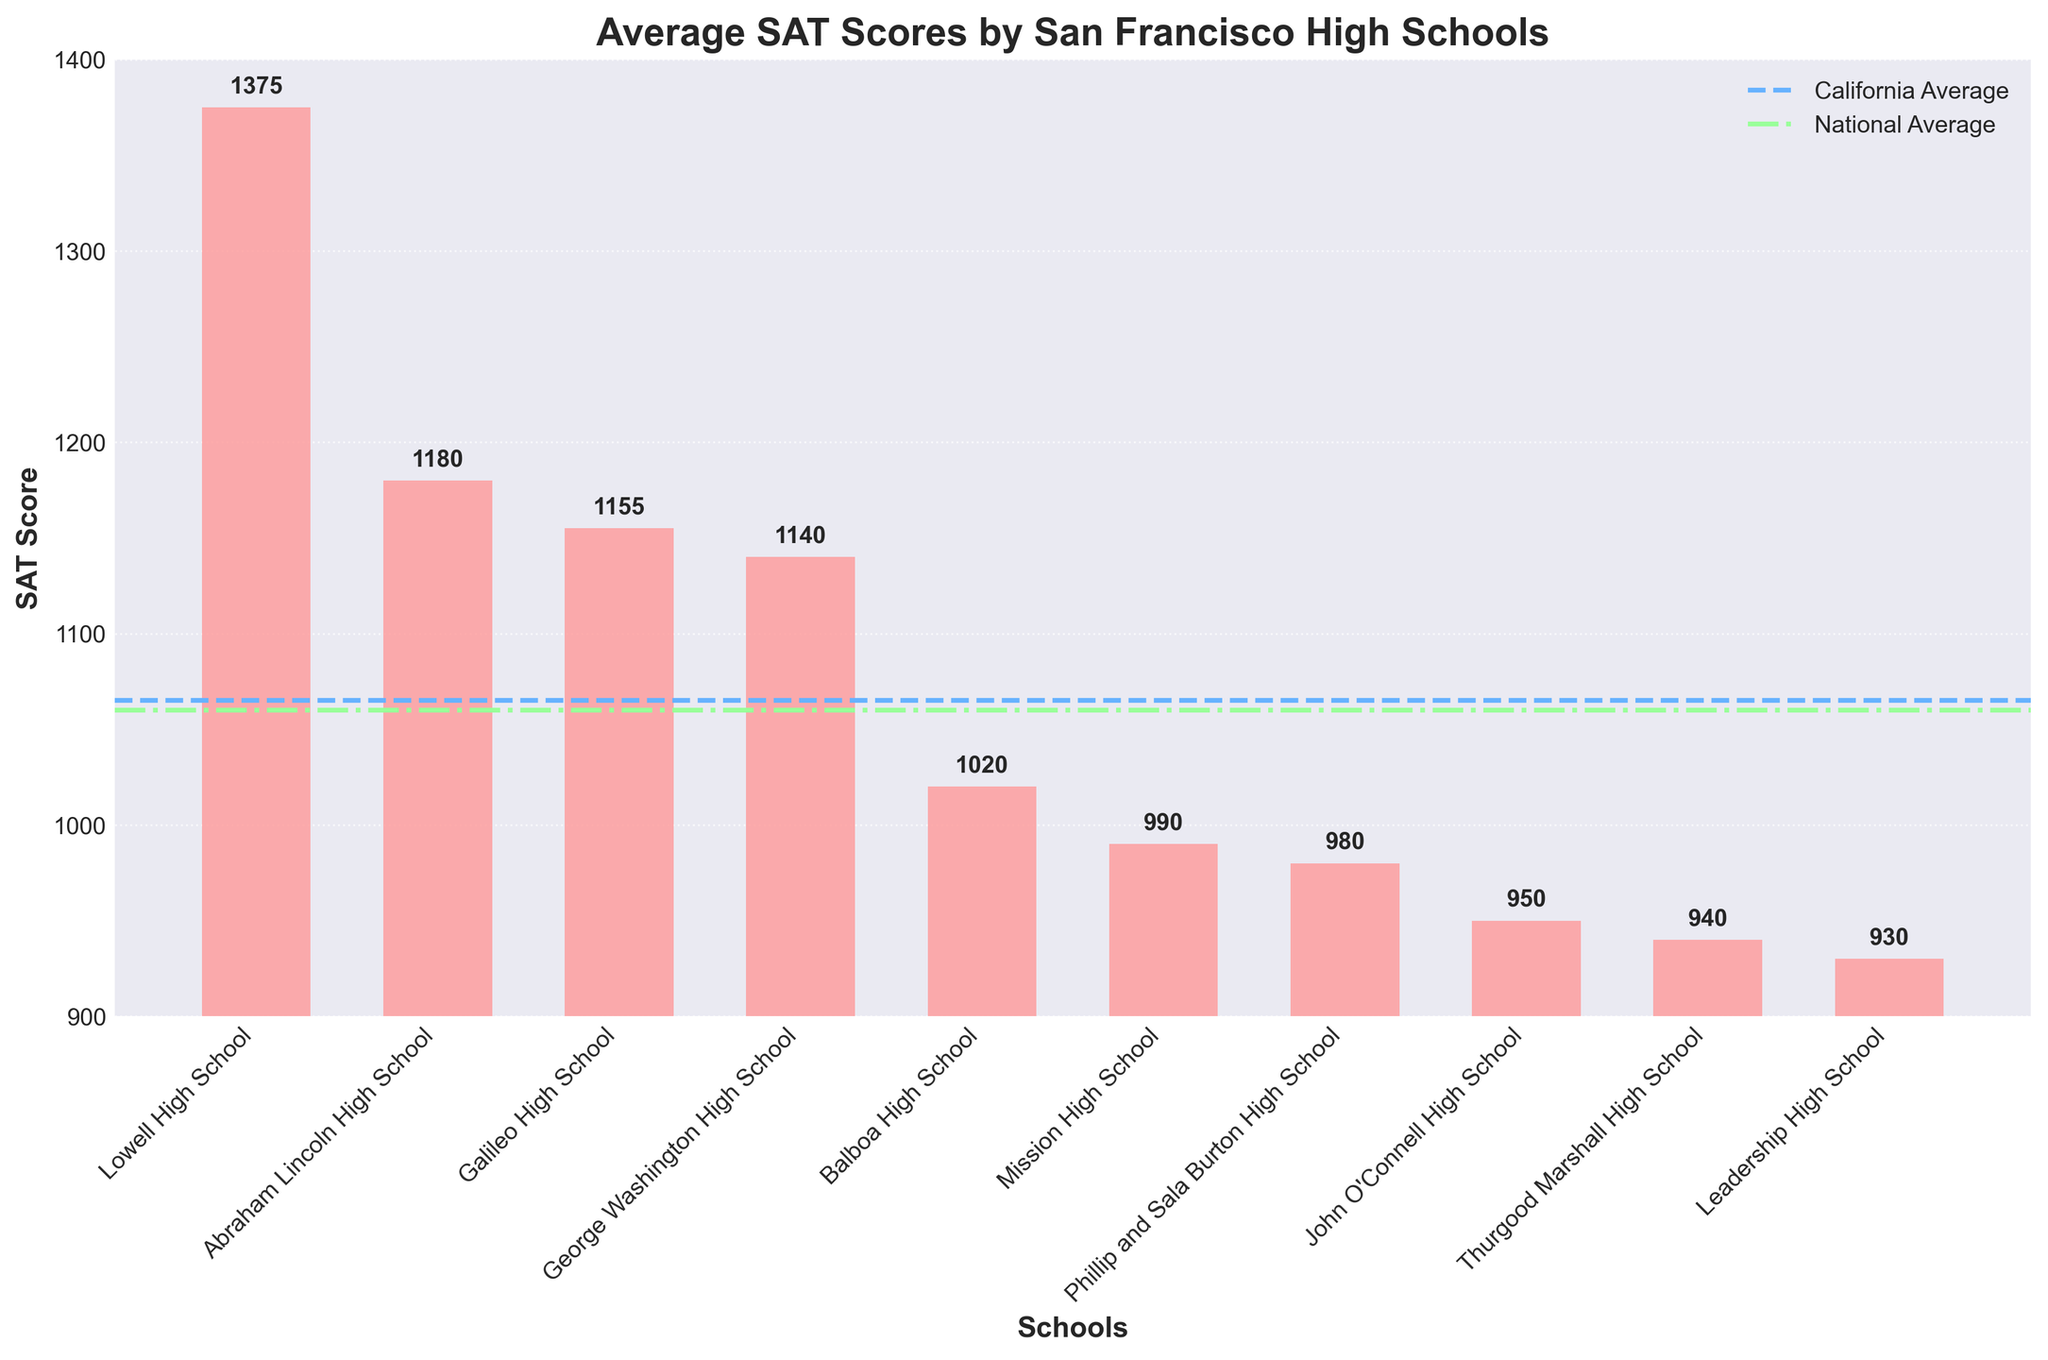Which school has the highest SAT score? By observing the height of the bars in the bar chart, Lowell High School has the tallest bar, indicating it has the highest SAT score.
Answer: Lowell High School How much higher is Lowell High School's SAT score compared to the California average? The SAT score for Lowell High School is 1375. The California average is 1065. To find the difference, subtract the California average from Lowell's score: 1375 - 1065 = 310.
Answer: 310 What is the difference between the highest and lowest SAT scores among the listed schools? The highest SAT score is from Lowell High School at 1375, and the lowest SAT score is from Leadership High School at 930. Subtract the lowest score from the highest: 1375 - 930 = 445.
Answer: 445 Which schools have SAT scores below both the California and National averages? Schools with SAT scores below both the California average (1065) and National average (1060) are those whose bars fall below these reference lines. These schools are Balboa High School, Mission High School, Phillip and Sala Burton High School, John O'Connell High School, Thurgood Marshall High School, and Leadership High School.
Answer: Balboa High School, Mission High School, Phillip and Sala Burton High School, John O'Connell High School, Thurgood Marshall High School, Leadership High School Which school has an SAT score closest to the National average? The National average SAT score is 1060. By comparing the bars, Balboa High School has an SAT score of 1020, which is the closest to the National average.
Answer: Balboa High School How much higher is the California average SAT score than the SAT score of Thurgood Marshall High School? The California average SAT score is 1065. Thurgood Marshall High School's SAT score is 940. Subtract Thurgood Marshall High School's score from the California average: 1065 - 940 = 125.
Answer: 125 What is the average SAT score of all the listed San Francisco high schools? First sum all the SAT scores (1375 + 1180 + 1155 + 1140 + 1020 + 990 + 980 + 950 + 940 + 930) = 10660. Then divide by the number of schools (10): 10660 / 10 = 1066.
Answer: 1066 Which school's SAT score is just below the average SAT score of all listed San Francisco schools? The average SAT score for the listed San Francisco schools is 1066. By checking the SAT scores, Balboa High School with a score of 1020 is just below this average.
Answer: Balboa High School What is the median SAT score among the listed schools? To find the median, first list the scores in ascending order: 930, 940, 950, 980, 990, 1020, 1140, 1155, 1180, 1375. The median is the average of the 5th and 6th scores (990 + 1020) / 2 = 1005.
Answer: 1005 How many schools have SAT scores above the California average? By comparing each bar's height to the California average line, schools with scores above the California average (1065) are Lowell High School, Abraham Lincoln High School, Galileo High School, and George Washington High School. There are 4 schools in total.
Answer: 4 